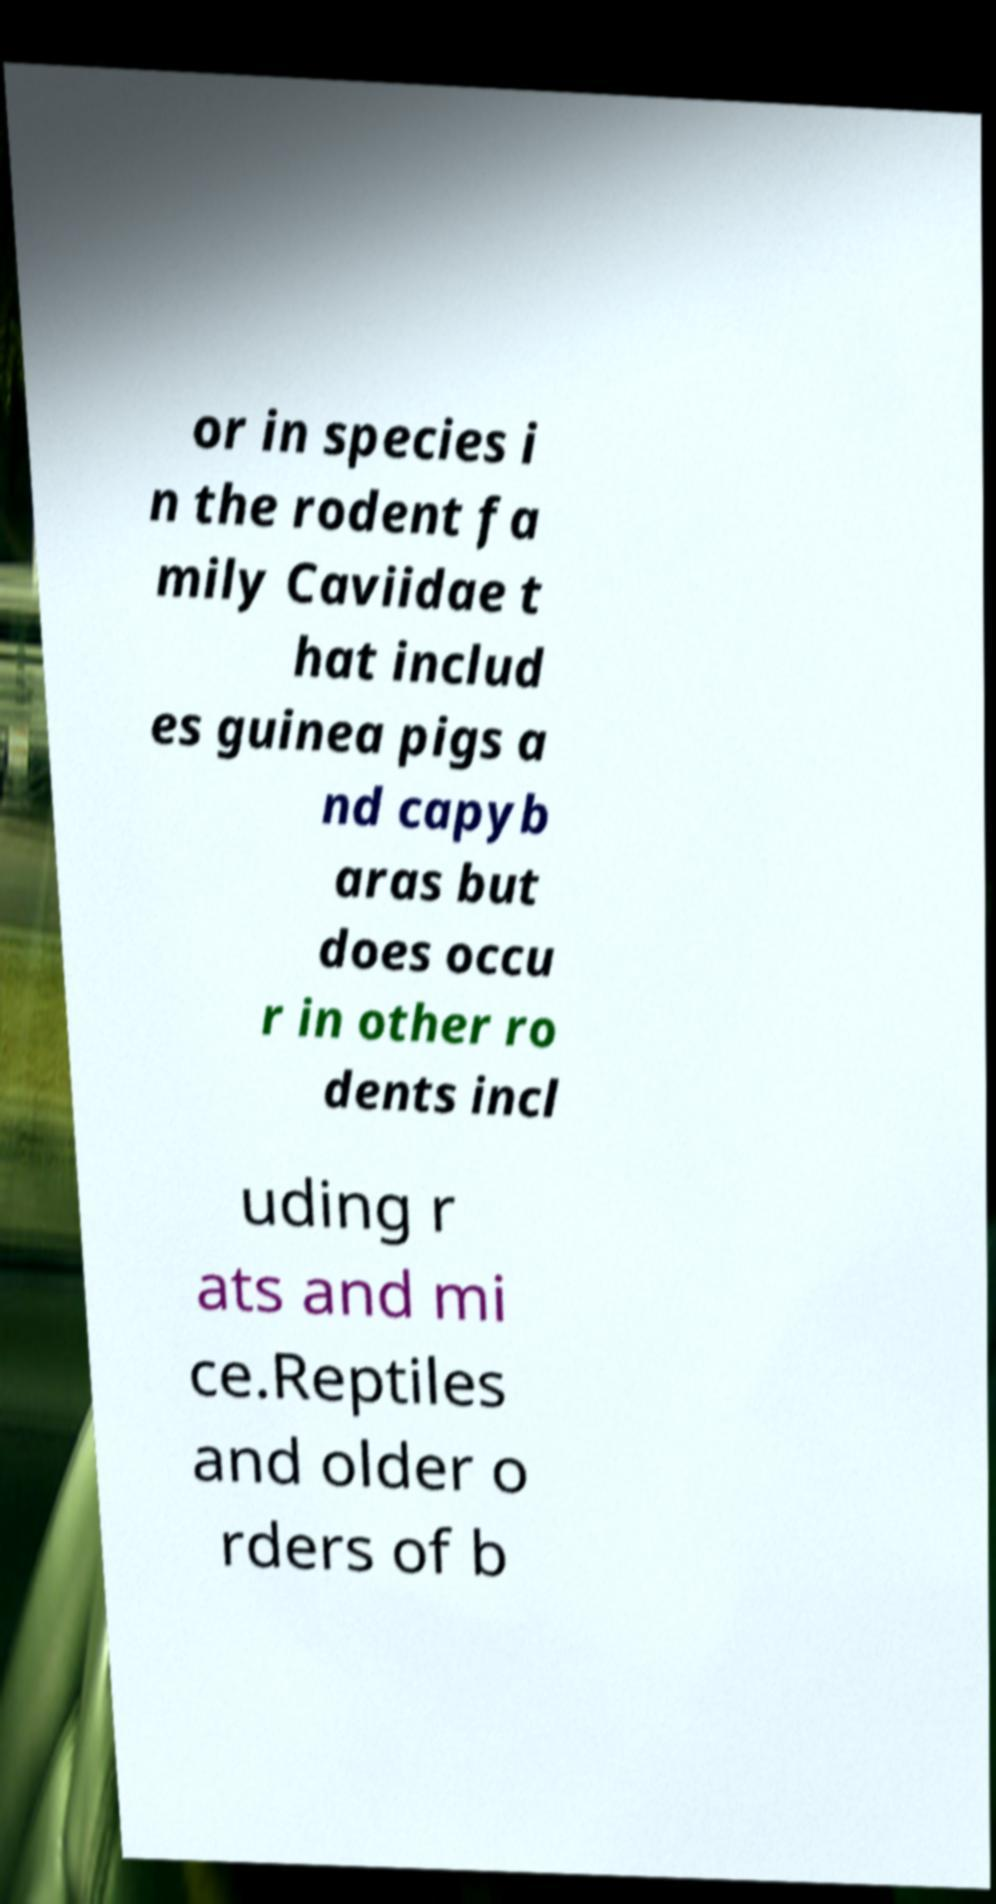I need the written content from this picture converted into text. Can you do that? or in species i n the rodent fa mily Caviidae t hat includ es guinea pigs a nd capyb aras but does occu r in other ro dents incl uding r ats and mi ce.Reptiles and older o rders of b 